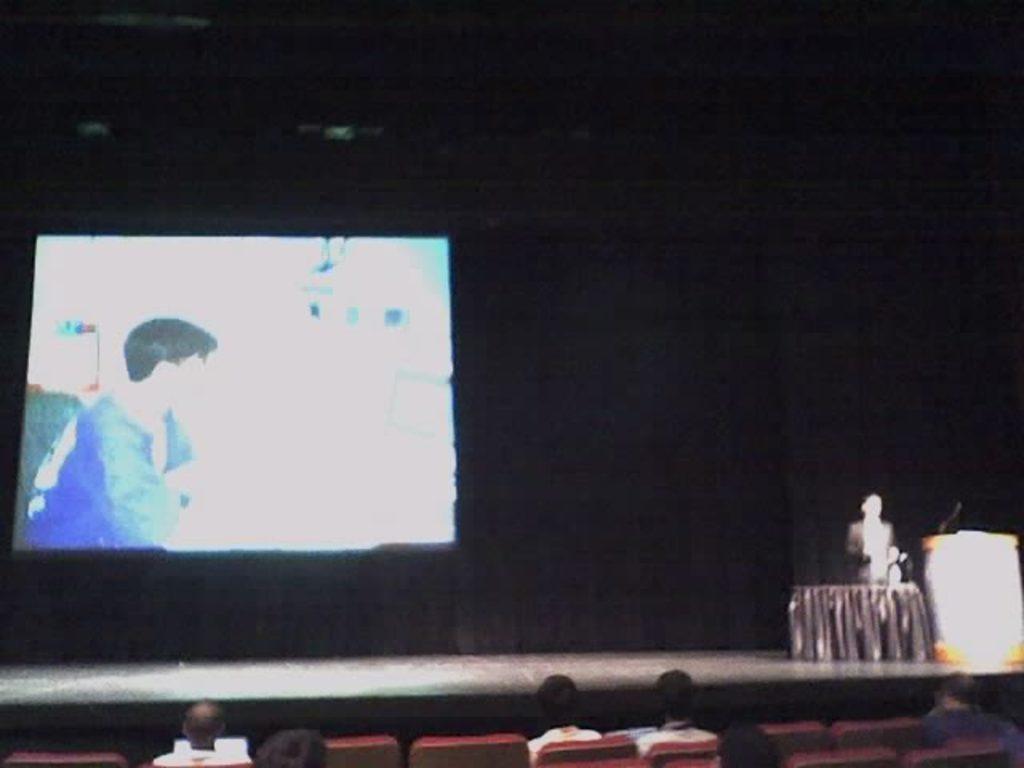Please provide a concise description of this image. There are people sitting and chairs at the bottom side of the image, there is a person standing, mic on a desk, screen and curtains in the background. 